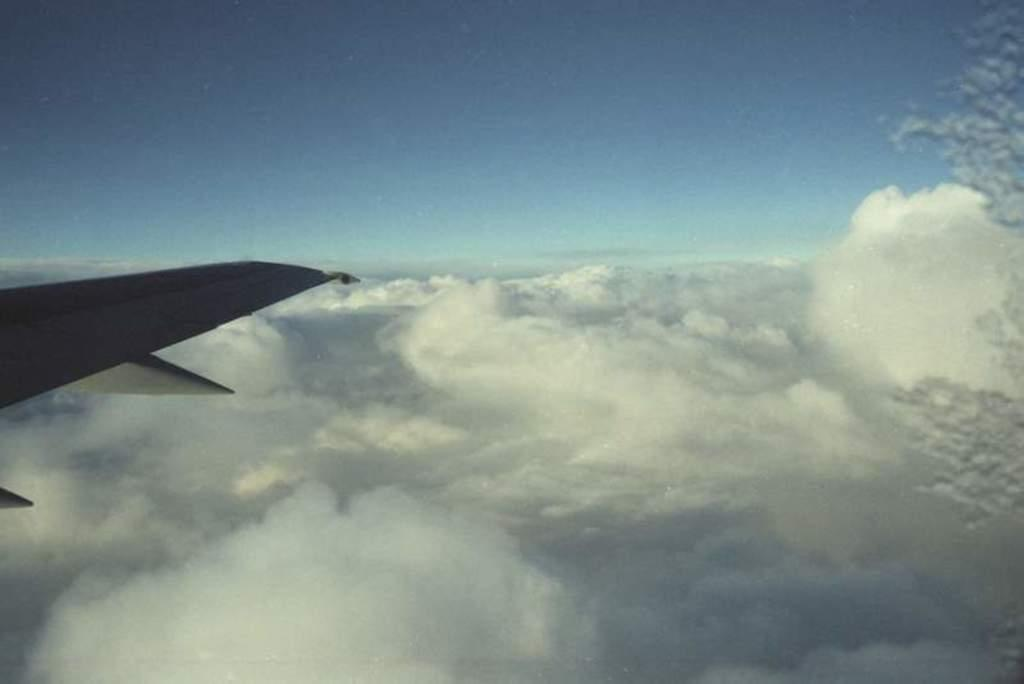What is the main subject of the image? The main subject of the image is an airplane wing. What can be seen in the background of the image? The sky is visible in the background of the image. What is the condition of the sky in the image? Clouds are present in the sky. How does the airplane wing pull the clouds in the image? The airplane wing does not pull the clouds in the image; the clouds are present in the sky independently of the airplane wing. 